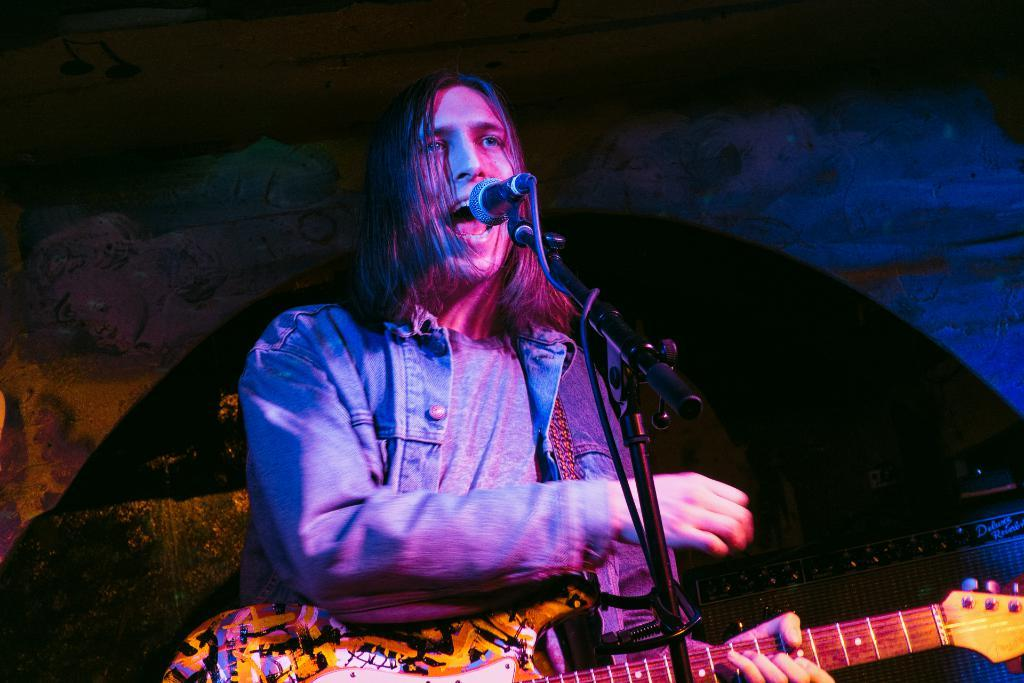What is the person in the image doing? The person is standing and holding a guitar. What object is placed on a stand in the image? There is a mic placed on a stand. What can be seen in the background of the image? There is a board in the background of the image. What type of jelly is being used to tune the guitar in the image? There is no jelly present in the image, and the guitar is not being tuned. 